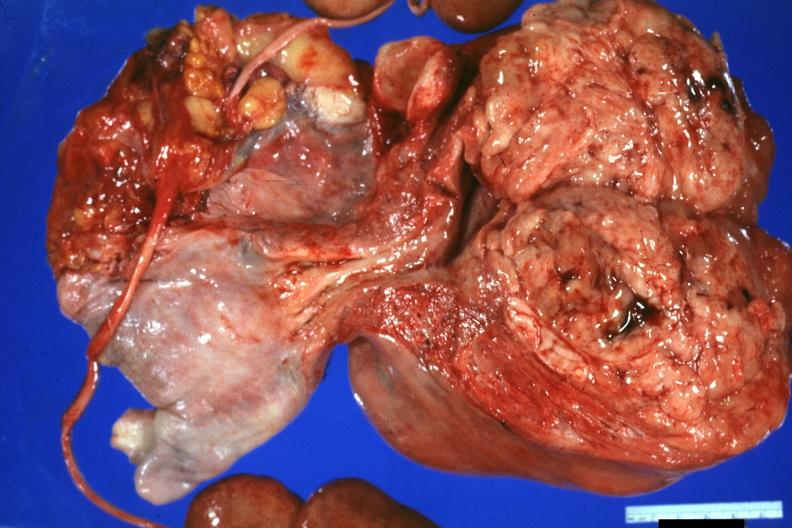s leiomyosarcoma present?
Answer the question using a single word or phrase. Yes 